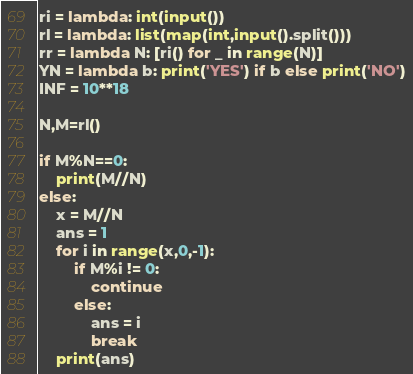<code> <loc_0><loc_0><loc_500><loc_500><_Python_>ri = lambda: int(input())
rl = lambda: list(map(int,input().split()))
rr = lambda N: [ri() for _ in range(N)]
YN = lambda b: print('YES') if b else print('NO')
INF = 10**18

N,M=rl()

if M%N==0:
    print(M//N)
else:
    x = M//N
    ans = 1
    for i in range(x,0,-1):
        if M%i != 0:
            continue
        else:
            ans = i
            break
    print(ans)</code> 